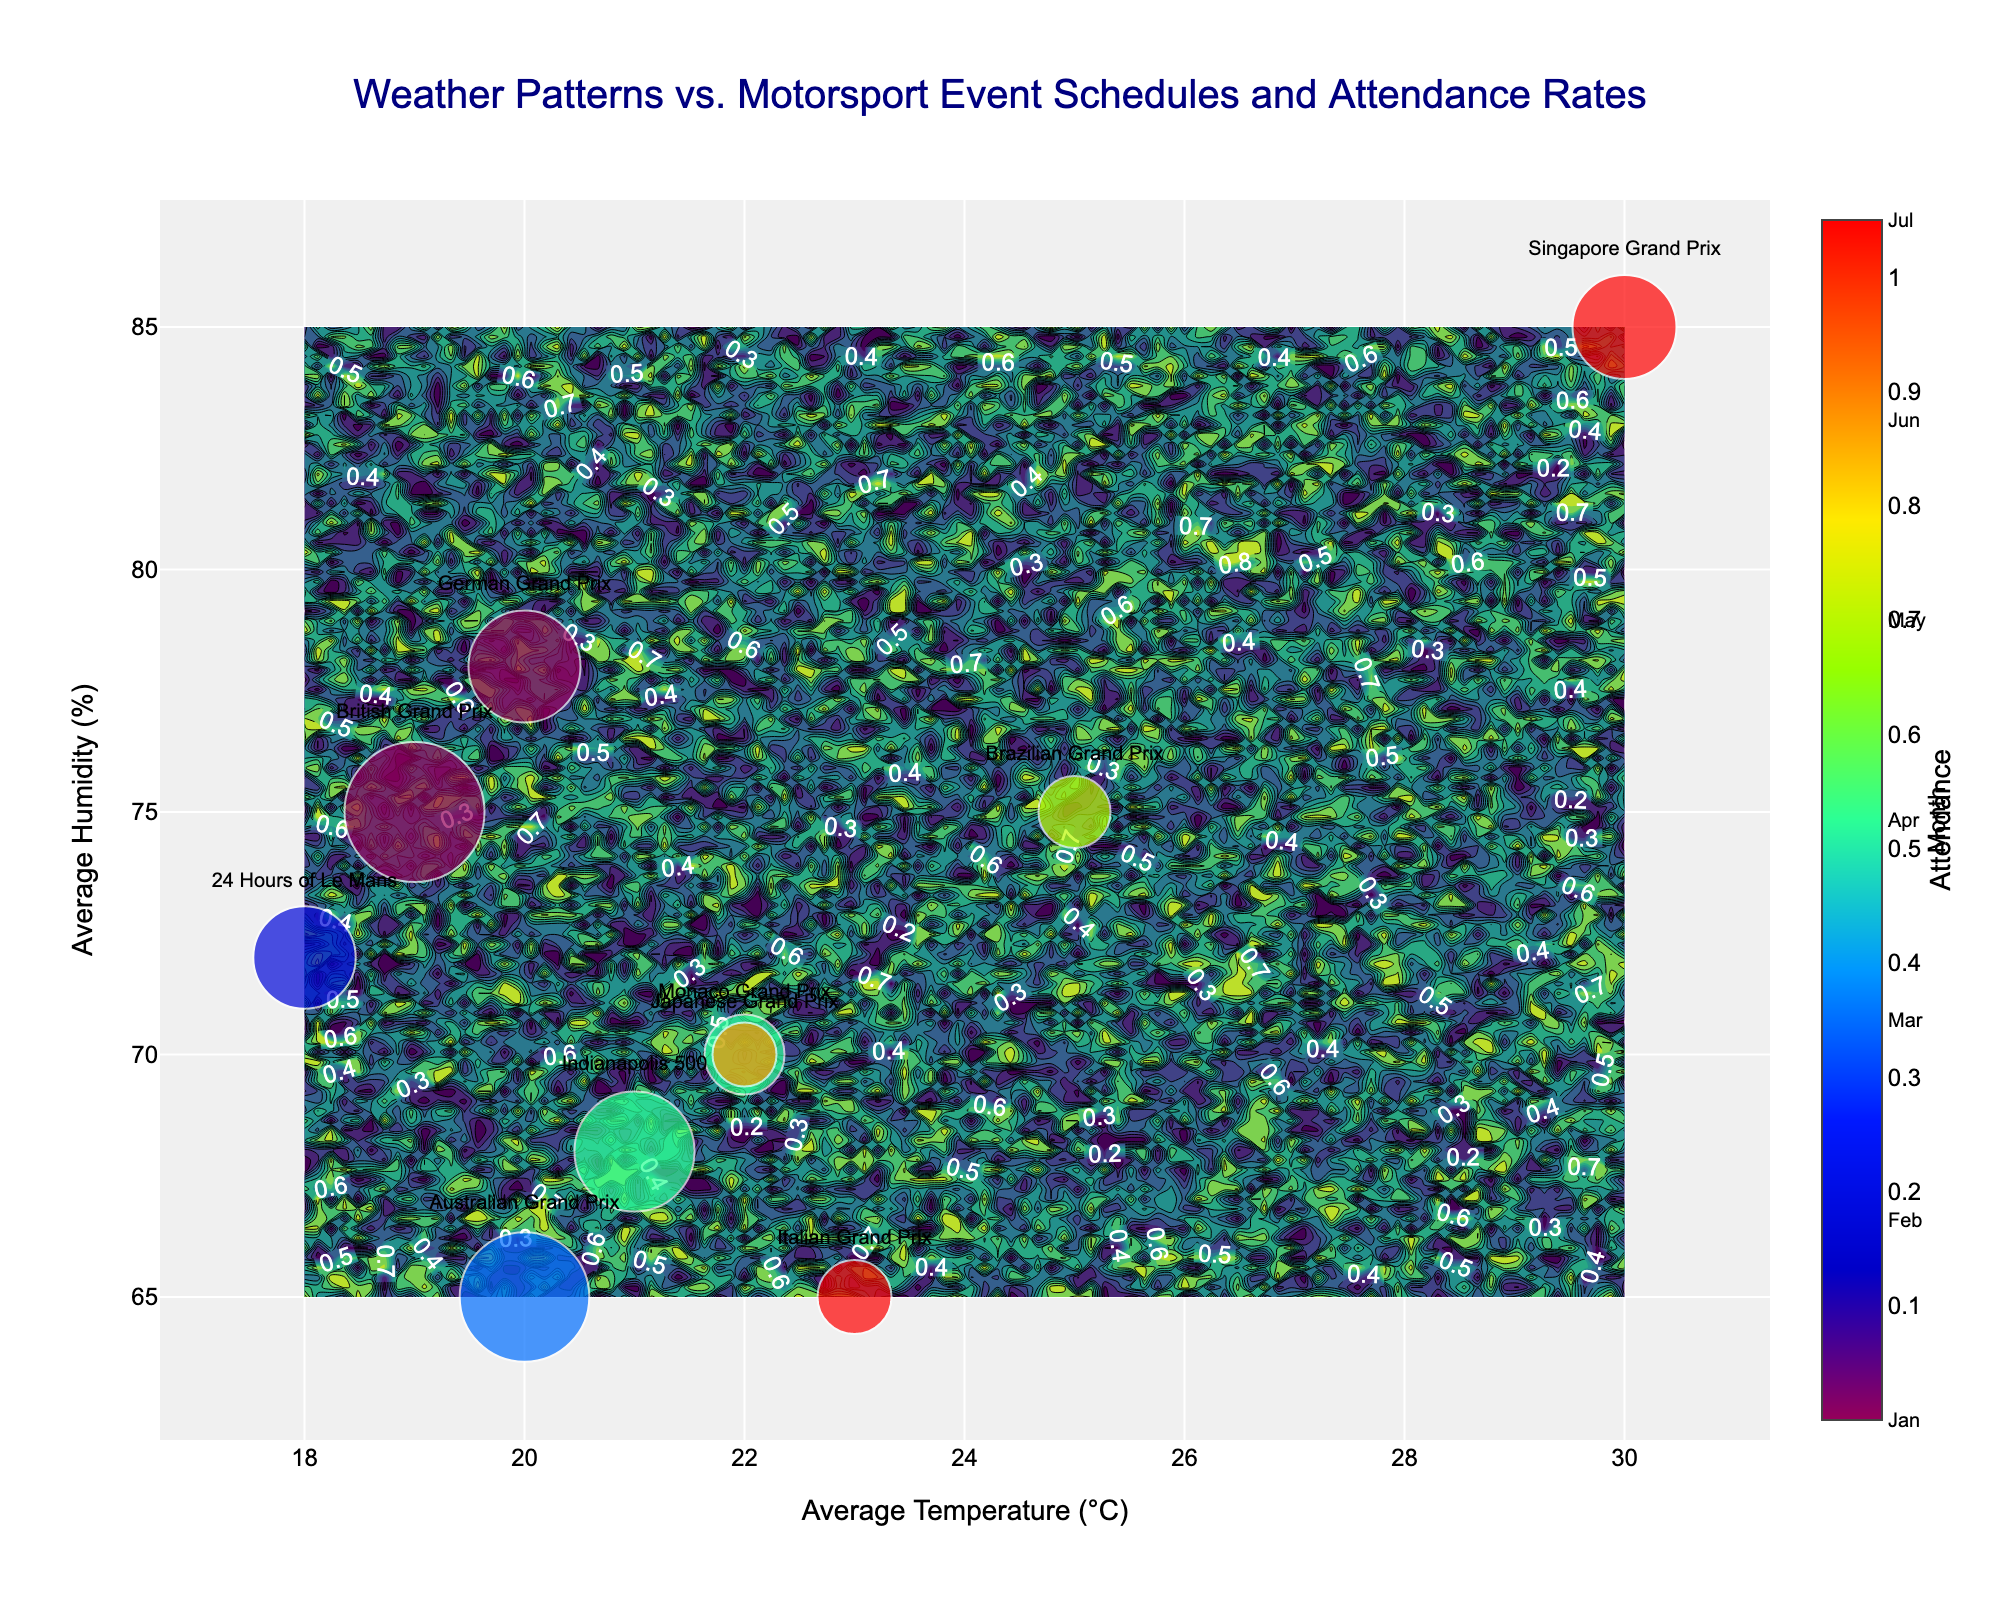What's the title of the figure? By looking at the title positioned at the top of the figure, we can identify it.
Answer: Weather Patterns vs. Motorsport Event Schedules and Attendance Rates What is the x-axis labeled as? The x-axis is labeled at the bottom of the chart area, specifying what variable is plotted along the horizontal axis.
Answer: Average Temperature (°C) Which event has the highest attendance? Locate the largest scatter point on the plot, as larger markers indicate higher attendance.
Answer: British Grand Prix During which months do the majority of the events occur? By observing the color scale representing months and examining the scatter plot colors, we can identify the most common months.
Answer: May, July, September Which event happens in the location with the highest average temperature? Find the event marker furthest to the right on the x-axis, as this indicates the highest average temperature.
Answer: Singapore Grand Prix How many events take place when humidity is around 70%? Count the number of markers placed approximately at 70% on the y-axis, regardless of the x-axis position.
Answer: 3 What is the average temperature and humidity for events in September? First, identify the points color-coded for September. Then, average their x (temperature) and y (humidity) positions.
Answer: Avg Temp: 26.5°C, Avg Humidity: 75% Which event takes place in the lowest humidity conditions? Look for the event closest to the bottom of the y-axis where the humidity is the lowest.
Answer: Australian Grand Prix Do higher attendance events tend to occur in higher or lower average temperatures? By examining the sizes of the markers and their positions along the x-axis (temperature), a trend can be identified.
Answer: Higher average temperatures Compare the attendance of the Monaco Grand Prix and the Brazilian Grand Prix. Which one has higher attendance? By locating each event by name and comparing marker sizes, the larger marker indicates higher attendance.
Answer: Monaco Grand Prix 